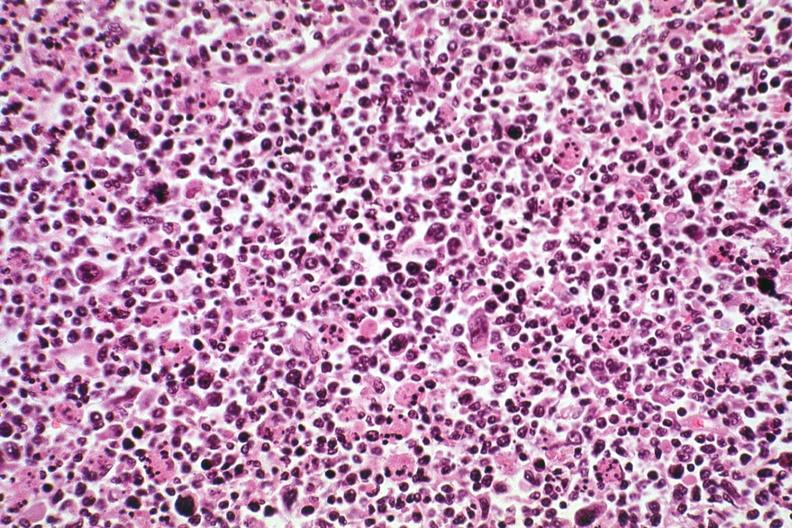s acute monocytic leukemia present?
Answer the question using a single word or phrase. No 